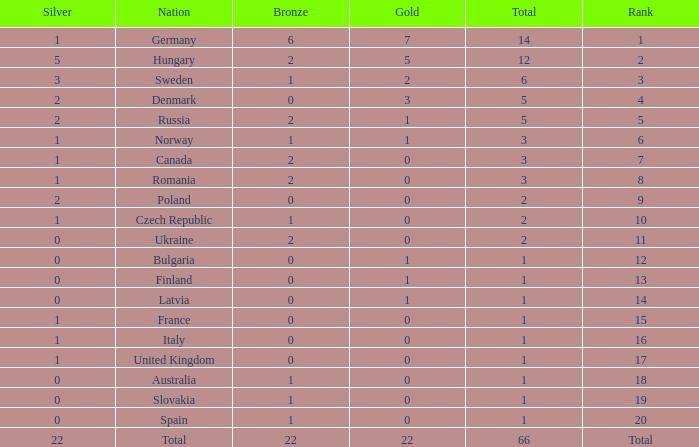What is the fewest number of silver medals won by Canada with fewer than 3 total medals? None. 